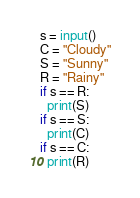<code> <loc_0><loc_0><loc_500><loc_500><_Python_>s = input()
C = "Cloudy"
S = "Sunny"
R = "Rainy"
if s == R:
  print(S)
if s == S:
  print(C)
if s == C:
  print(R)</code> 